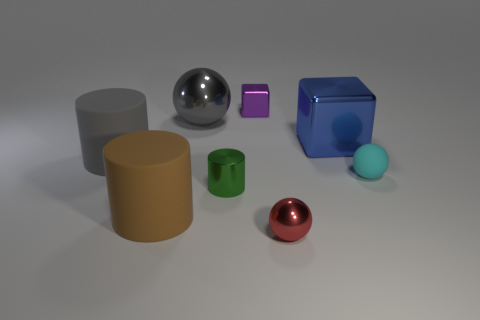There is a brown thing; is its size the same as the metallic ball behind the small green metallic cylinder?
Provide a short and direct response. Yes. The large matte thing that is behind the small green cylinder that is on the left side of the purple shiny thing is what shape?
Ensure brevity in your answer.  Cylinder. Are there fewer metal things to the right of the large cube than small blue matte cylinders?
Offer a terse response. No. What shape is the big matte thing that is the same color as the large metallic ball?
Offer a very short reply. Cylinder. How many objects have the same size as the gray metallic ball?
Your answer should be very brief. 3. There is a big shiny thing on the left side of the purple shiny block; what is its shape?
Make the answer very short. Sphere. Is the number of big brown things less than the number of large red things?
Provide a succinct answer. No. Is there anything else that is the same color as the big sphere?
Offer a terse response. Yes. What size is the sphere in front of the tiny green thing?
Your answer should be very brief. Small. Is the number of gray rubber objects greater than the number of big cyan things?
Keep it short and to the point. Yes. 